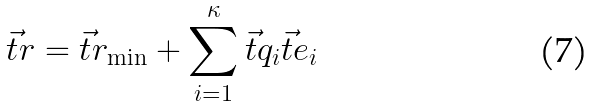<formula> <loc_0><loc_0><loc_500><loc_500>\vec { t } { r } = \vec { t } { r } _ { \min } + \sum _ { i = 1 } ^ { \kappa } \vec { t } { q } _ { i } \vec { t } { e } _ { i }</formula> 